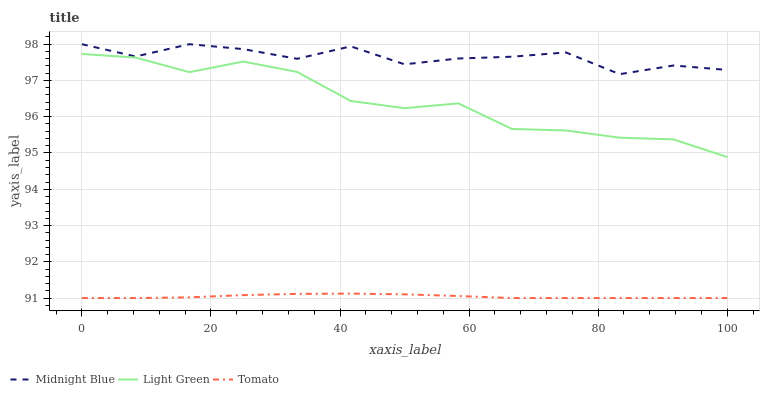Does Tomato have the minimum area under the curve?
Answer yes or no. Yes. Does Midnight Blue have the maximum area under the curve?
Answer yes or no. Yes. Does Light Green have the minimum area under the curve?
Answer yes or no. No. Does Light Green have the maximum area under the curve?
Answer yes or no. No. Is Tomato the smoothest?
Answer yes or no. Yes. Is Midnight Blue the roughest?
Answer yes or no. Yes. Is Light Green the smoothest?
Answer yes or no. No. Is Light Green the roughest?
Answer yes or no. No. Does Light Green have the lowest value?
Answer yes or no. No. Does Midnight Blue have the highest value?
Answer yes or no. Yes. Does Light Green have the highest value?
Answer yes or no. No. Is Tomato less than Midnight Blue?
Answer yes or no. Yes. Is Midnight Blue greater than Tomato?
Answer yes or no. Yes. Does Tomato intersect Midnight Blue?
Answer yes or no. No. 